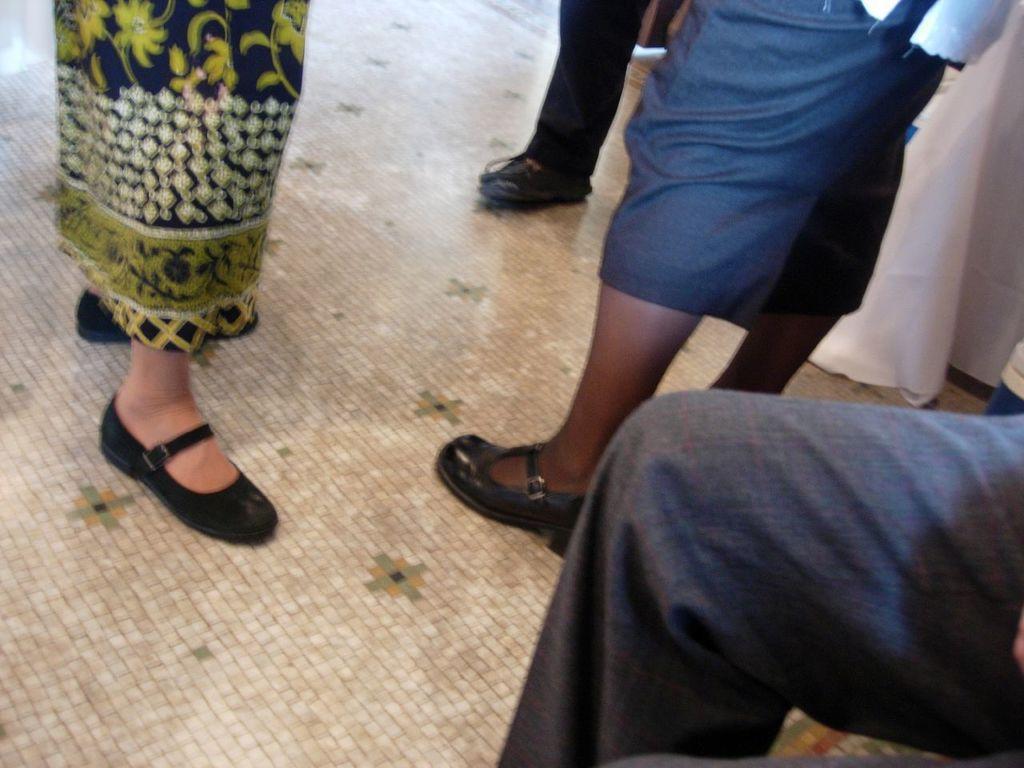Please provide a concise description of this image. This picture consists of persons legs and shoes visible on floor. 